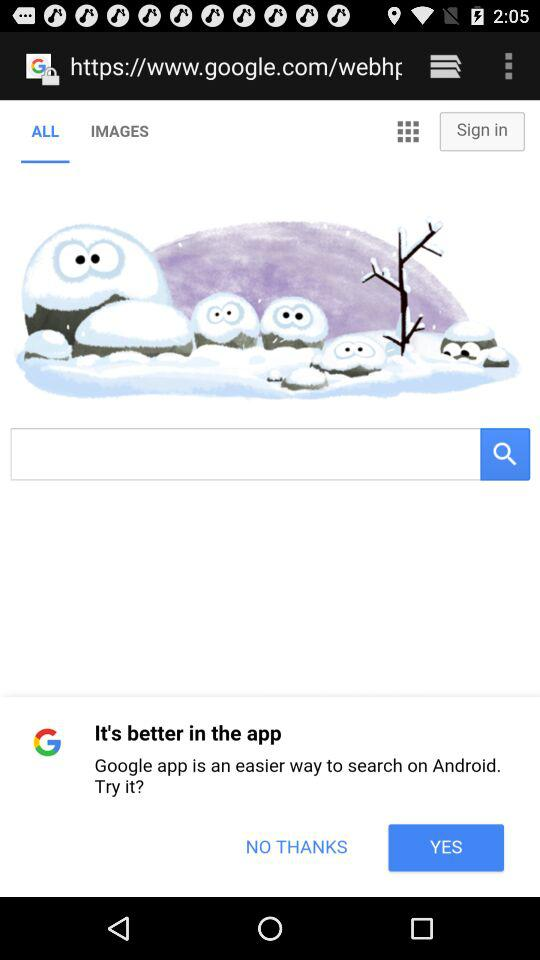What is entered in the search bar?
When the provided information is insufficient, respond with <no answer>. <no answer> 